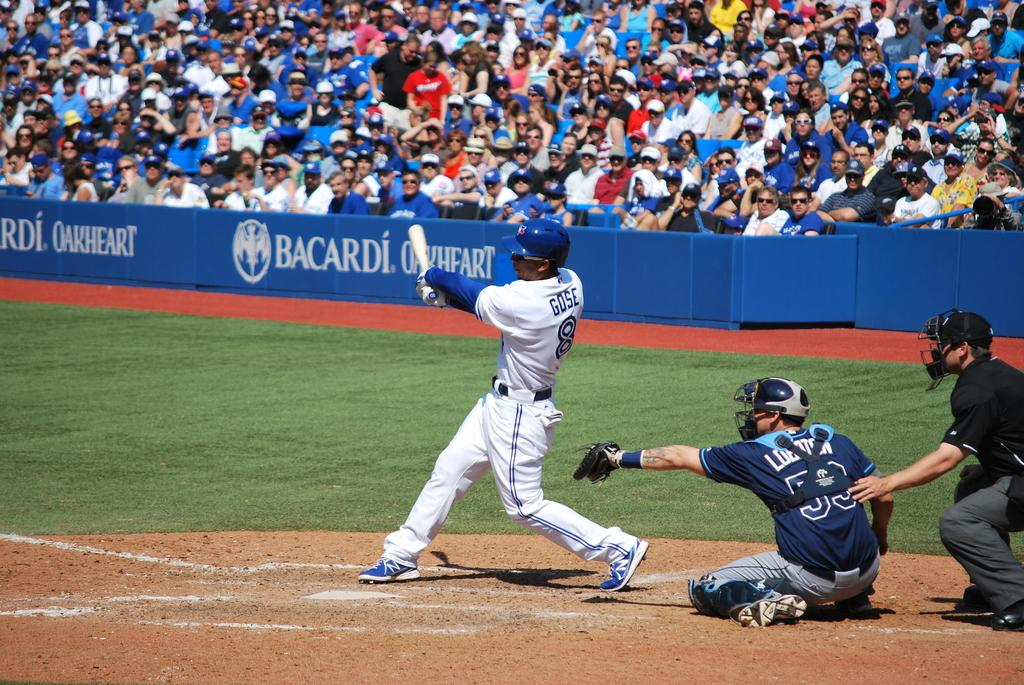Provide a one-sentence caption for the provided image. A Player is hitting a ball with the last name Gose on his back. 